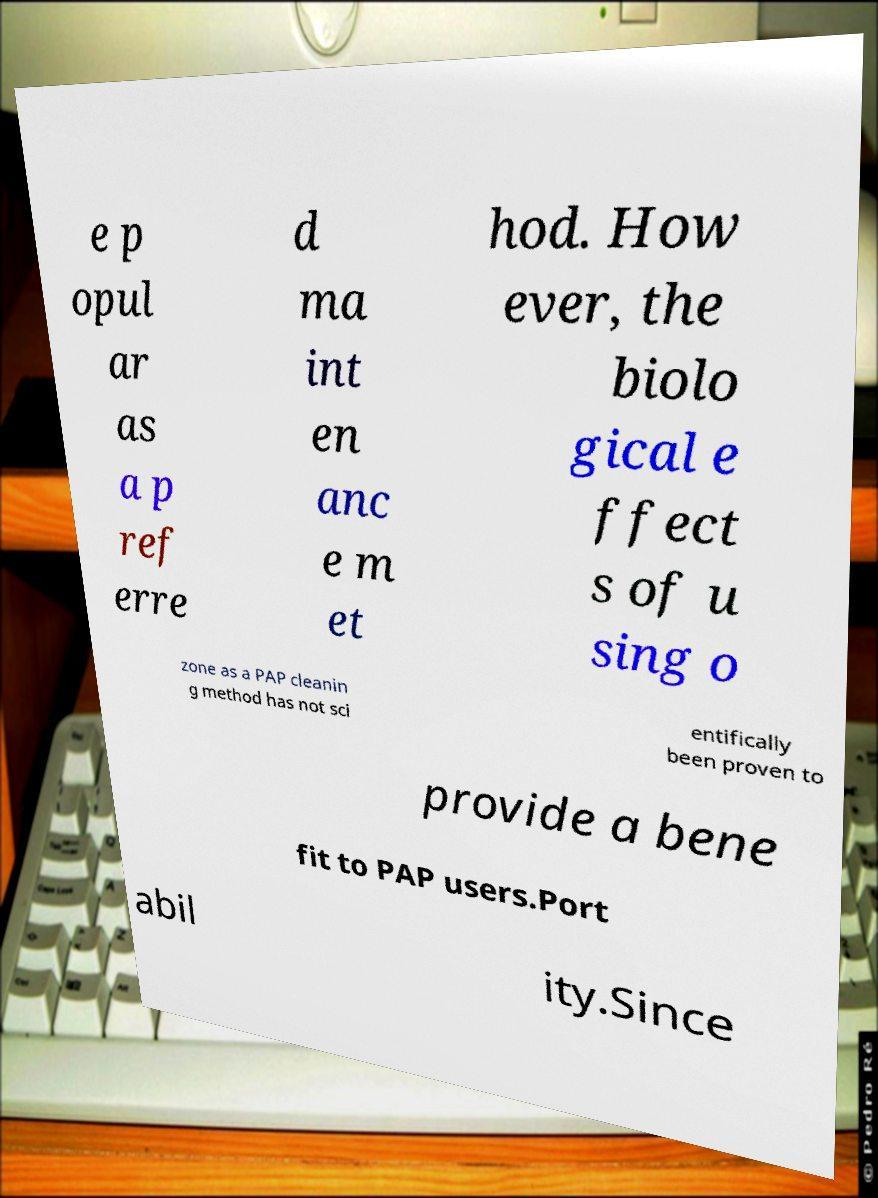Please read and relay the text visible in this image. What does it say? e p opul ar as a p ref erre d ma int en anc e m et hod. How ever, the biolo gical e ffect s of u sing o zone as a PAP cleanin g method has not sci entifically been proven to provide a bene fit to PAP users.Port abil ity.Since 